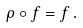Convert formula to latex. <formula><loc_0><loc_0><loc_500><loc_500>\rho \circ f = f \, .</formula> 